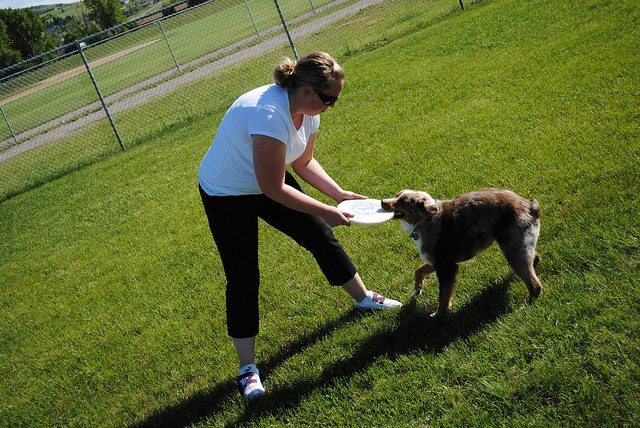Describe the objects in this image and their specific colors. I can see people in lightblue, black, maroon, and gray tones, dog in lightblue, black, white, gray, and darkgray tones, and frisbee in lightblue, white, gray, and darkgray tones in this image. 